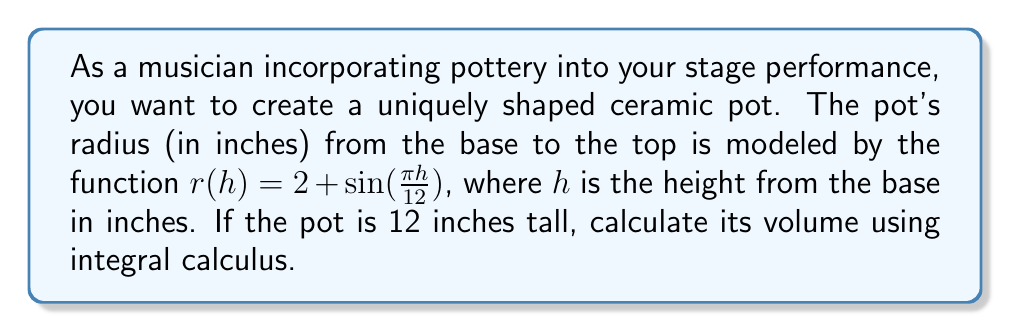Can you answer this question? To find the volume of the pot, we need to use the formula for the volume of a solid of revolution:

$$ V = \pi \int_0^h [r(h)]^2 \, dh $$

where $r(h)$ is the radius function and $h$ is the height.

Step 1: Substitute the given function and limits:
$$ V = \pi \int_0^{12} [2 + \sin(\frac{\pi h}{12})]^2 \, dh $$

Step 2: Expand the squared term:
$$ V = \pi \int_0^{12} [4 + 4\sin(\frac{\pi h}{12}) + \sin^2(\frac{\pi h}{12})] \, dh $$

Step 3: Integrate each term separately:

a) $\int 4 \, dh = 4h$

b) $\int 4\sin(\frac{\pi h}{12}) \, dh = -\frac{48}{\pi}\cos(\frac{\pi h}{12})$

c) $\int \sin^2(\frac{\pi h}{12}) \, dh = \frac{h}{2} - \frac{6}{\pi}\sin(\frac{\pi h}{6})$

Step 4: Apply the limits of integration:

$$ V = \pi \left[ 4h - \frac{48}{\pi}\cos(\frac{\pi h}{12}) + \frac{h}{2} - \frac{6}{\pi}\sin(\frac{\pi h}{6}) \right]_0^{12} $$

Step 5: Evaluate and simplify:

$$ V = \pi \left[ (48 - 0) - \frac{48}{\pi}(1 - 1) + (6 - 0) - \frac{6}{\pi}(0 - 0) \right] $$
$$ V = 54\pi \approx 169.65 \text{ cubic inches} $$
Answer: $54\pi$ cubic inches 